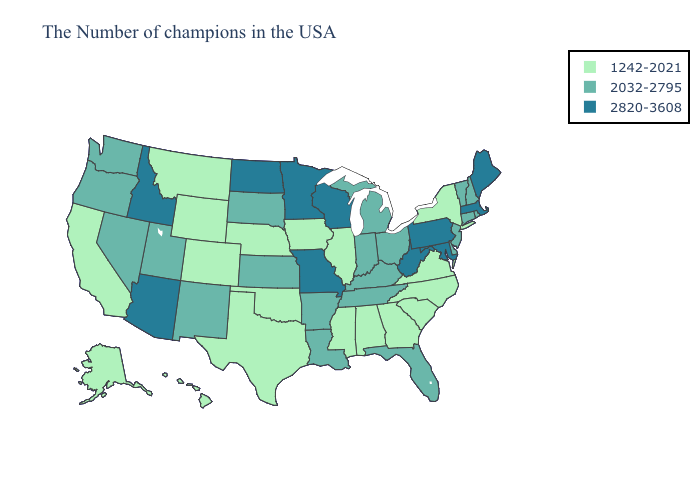Which states have the highest value in the USA?
Write a very short answer. Maine, Massachusetts, Maryland, Pennsylvania, West Virginia, Wisconsin, Missouri, Minnesota, North Dakota, Arizona, Idaho. What is the highest value in the West ?
Short answer required. 2820-3608. Does New Mexico have the highest value in the USA?
Short answer required. No. Name the states that have a value in the range 2820-3608?
Answer briefly. Maine, Massachusetts, Maryland, Pennsylvania, West Virginia, Wisconsin, Missouri, Minnesota, North Dakota, Arizona, Idaho. Does Missouri have the highest value in the USA?
Keep it brief. Yes. Does South Dakota have a lower value than Montana?
Quick response, please. No. Name the states that have a value in the range 2820-3608?
Keep it brief. Maine, Massachusetts, Maryland, Pennsylvania, West Virginia, Wisconsin, Missouri, Minnesota, North Dakota, Arizona, Idaho. Name the states that have a value in the range 2820-3608?
Answer briefly. Maine, Massachusetts, Maryland, Pennsylvania, West Virginia, Wisconsin, Missouri, Minnesota, North Dakota, Arizona, Idaho. Does Mississippi have the highest value in the South?
Keep it brief. No. Does Utah have the highest value in the USA?
Quick response, please. No. How many symbols are there in the legend?
Write a very short answer. 3. Which states have the highest value in the USA?
Keep it brief. Maine, Massachusetts, Maryland, Pennsylvania, West Virginia, Wisconsin, Missouri, Minnesota, North Dakota, Arizona, Idaho. What is the lowest value in the Northeast?
Quick response, please. 1242-2021. What is the lowest value in the Northeast?
Write a very short answer. 1242-2021. Name the states that have a value in the range 1242-2021?
Concise answer only. New York, Virginia, North Carolina, South Carolina, Georgia, Alabama, Illinois, Mississippi, Iowa, Nebraska, Oklahoma, Texas, Wyoming, Colorado, Montana, California, Alaska, Hawaii. 